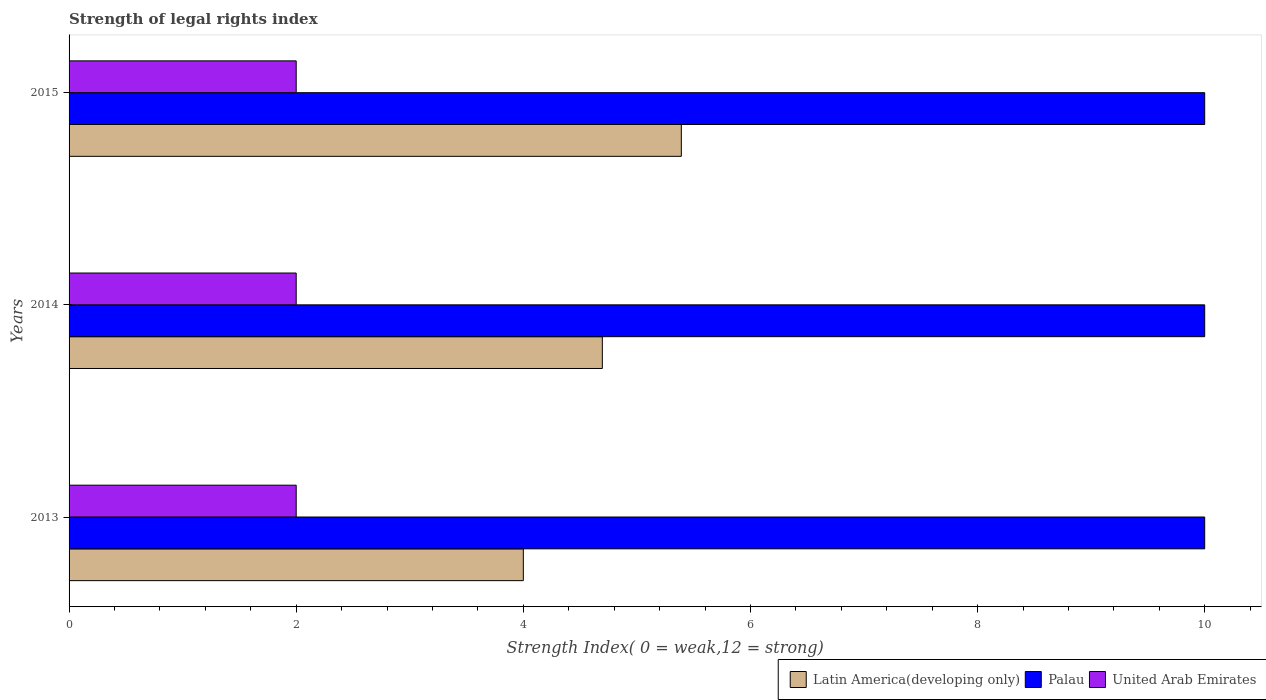How many bars are there on the 1st tick from the top?
Keep it short and to the point. 3. In how many cases, is the number of bars for a given year not equal to the number of legend labels?
Your response must be concise. 0. What is the strength index in Latin America(developing only) in 2015?
Your response must be concise. 5.39. Across all years, what is the maximum strength index in Palau?
Your response must be concise. 10. Across all years, what is the minimum strength index in Latin America(developing only)?
Make the answer very short. 4. In which year was the strength index in United Arab Emirates minimum?
Ensure brevity in your answer.  2013. What is the total strength index in Latin America(developing only) in the graph?
Make the answer very short. 14.09. What is the difference between the strength index in Latin America(developing only) in 2013 and that in 2014?
Provide a succinct answer. -0.7. What is the difference between the strength index in Latin America(developing only) in 2014 and the strength index in United Arab Emirates in 2013?
Provide a short and direct response. 2.7. What is the average strength index in Latin America(developing only) per year?
Offer a terse response. 4.7. In the year 2014, what is the difference between the strength index in United Arab Emirates and strength index in Latin America(developing only)?
Offer a terse response. -2.7. Is the strength index in Palau in 2013 less than that in 2014?
Your response must be concise. No. What is the difference between the highest and the second highest strength index in Palau?
Make the answer very short. 0. What is the difference between the highest and the lowest strength index in Latin America(developing only)?
Your answer should be compact. 1.39. In how many years, is the strength index in United Arab Emirates greater than the average strength index in United Arab Emirates taken over all years?
Ensure brevity in your answer.  0. Is the sum of the strength index in United Arab Emirates in 2013 and 2015 greater than the maximum strength index in Latin America(developing only) across all years?
Give a very brief answer. No. What does the 2nd bar from the top in 2014 represents?
Your answer should be very brief. Palau. What does the 3rd bar from the bottom in 2015 represents?
Provide a short and direct response. United Arab Emirates. Is it the case that in every year, the sum of the strength index in Palau and strength index in Latin America(developing only) is greater than the strength index in United Arab Emirates?
Your response must be concise. Yes. How many bars are there?
Ensure brevity in your answer.  9. What is the difference between two consecutive major ticks on the X-axis?
Keep it short and to the point. 2. Does the graph contain any zero values?
Give a very brief answer. No. Does the graph contain grids?
Ensure brevity in your answer.  No. Where does the legend appear in the graph?
Provide a short and direct response. Bottom right. How many legend labels are there?
Make the answer very short. 3. How are the legend labels stacked?
Your answer should be compact. Horizontal. What is the title of the graph?
Provide a short and direct response. Strength of legal rights index. Does "Heavily indebted poor countries" appear as one of the legend labels in the graph?
Offer a terse response. No. What is the label or title of the X-axis?
Give a very brief answer. Strength Index( 0 = weak,12 = strong). What is the Strength Index( 0 = weak,12 = strong) of Latin America(developing only) in 2013?
Offer a very short reply. 4. What is the Strength Index( 0 = weak,12 = strong) of Palau in 2013?
Your answer should be very brief. 10. What is the Strength Index( 0 = weak,12 = strong) of United Arab Emirates in 2013?
Your answer should be compact. 2. What is the Strength Index( 0 = weak,12 = strong) in Latin America(developing only) in 2014?
Provide a succinct answer. 4.7. What is the Strength Index( 0 = weak,12 = strong) in Latin America(developing only) in 2015?
Provide a short and direct response. 5.39. What is the Strength Index( 0 = weak,12 = strong) in United Arab Emirates in 2015?
Offer a terse response. 2. Across all years, what is the maximum Strength Index( 0 = weak,12 = strong) in Latin America(developing only)?
Your response must be concise. 5.39. Across all years, what is the maximum Strength Index( 0 = weak,12 = strong) in United Arab Emirates?
Ensure brevity in your answer.  2. Across all years, what is the minimum Strength Index( 0 = weak,12 = strong) in United Arab Emirates?
Give a very brief answer. 2. What is the total Strength Index( 0 = weak,12 = strong) of Latin America(developing only) in the graph?
Your answer should be compact. 14.09. What is the total Strength Index( 0 = weak,12 = strong) in Palau in the graph?
Make the answer very short. 30. What is the total Strength Index( 0 = weak,12 = strong) of United Arab Emirates in the graph?
Provide a succinct answer. 6. What is the difference between the Strength Index( 0 = weak,12 = strong) in Latin America(developing only) in 2013 and that in 2014?
Your response must be concise. -0.7. What is the difference between the Strength Index( 0 = weak,12 = strong) of Palau in 2013 and that in 2014?
Your answer should be compact. 0. What is the difference between the Strength Index( 0 = weak,12 = strong) of Latin America(developing only) in 2013 and that in 2015?
Offer a terse response. -1.39. What is the difference between the Strength Index( 0 = weak,12 = strong) of Latin America(developing only) in 2014 and that in 2015?
Provide a succinct answer. -0.7. What is the difference between the Strength Index( 0 = weak,12 = strong) in United Arab Emirates in 2014 and that in 2015?
Give a very brief answer. 0. What is the difference between the Strength Index( 0 = weak,12 = strong) of Latin America(developing only) in 2013 and the Strength Index( 0 = weak,12 = strong) of United Arab Emirates in 2014?
Your answer should be compact. 2. What is the difference between the Strength Index( 0 = weak,12 = strong) in Latin America(developing only) in 2013 and the Strength Index( 0 = weak,12 = strong) in Palau in 2015?
Provide a succinct answer. -6. What is the difference between the Strength Index( 0 = weak,12 = strong) of Latin America(developing only) in 2013 and the Strength Index( 0 = weak,12 = strong) of United Arab Emirates in 2015?
Offer a very short reply. 2. What is the difference between the Strength Index( 0 = weak,12 = strong) in Palau in 2013 and the Strength Index( 0 = weak,12 = strong) in United Arab Emirates in 2015?
Your answer should be very brief. 8. What is the difference between the Strength Index( 0 = weak,12 = strong) of Latin America(developing only) in 2014 and the Strength Index( 0 = weak,12 = strong) of Palau in 2015?
Provide a short and direct response. -5.3. What is the difference between the Strength Index( 0 = weak,12 = strong) of Latin America(developing only) in 2014 and the Strength Index( 0 = weak,12 = strong) of United Arab Emirates in 2015?
Offer a very short reply. 2.7. What is the difference between the Strength Index( 0 = weak,12 = strong) in Palau in 2014 and the Strength Index( 0 = weak,12 = strong) in United Arab Emirates in 2015?
Make the answer very short. 8. What is the average Strength Index( 0 = weak,12 = strong) of Latin America(developing only) per year?
Your answer should be compact. 4.7. In the year 2013, what is the difference between the Strength Index( 0 = weak,12 = strong) of Latin America(developing only) and Strength Index( 0 = weak,12 = strong) of Palau?
Keep it short and to the point. -6. In the year 2013, what is the difference between the Strength Index( 0 = weak,12 = strong) in Palau and Strength Index( 0 = weak,12 = strong) in United Arab Emirates?
Your answer should be very brief. 8. In the year 2014, what is the difference between the Strength Index( 0 = weak,12 = strong) of Latin America(developing only) and Strength Index( 0 = weak,12 = strong) of Palau?
Keep it short and to the point. -5.3. In the year 2014, what is the difference between the Strength Index( 0 = weak,12 = strong) in Latin America(developing only) and Strength Index( 0 = weak,12 = strong) in United Arab Emirates?
Keep it short and to the point. 2.7. In the year 2015, what is the difference between the Strength Index( 0 = weak,12 = strong) in Latin America(developing only) and Strength Index( 0 = weak,12 = strong) in Palau?
Give a very brief answer. -4.61. In the year 2015, what is the difference between the Strength Index( 0 = weak,12 = strong) of Latin America(developing only) and Strength Index( 0 = weak,12 = strong) of United Arab Emirates?
Offer a terse response. 3.39. In the year 2015, what is the difference between the Strength Index( 0 = weak,12 = strong) in Palau and Strength Index( 0 = weak,12 = strong) in United Arab Emirates?
Give a very brief answer. 8. What is the ratio of the Strength Index( 0 = weak,12 = strong) in Latin America(developing only) in 2013 to that in 2014?
Offer a terse response. 0.85. What is the ratio of the Strength Index( 0 = weak,12 = strong) in Latin America(developing only) in 2013 to that in 2015?
Offer a terse response. 0.74. What is the ratio of the Strength Index( 0 = weak,12 = strong) in Palau in 2013 to that in 2015?
Offer a terse response. 1. What is the ratio of the Strength Index( 0 = weak,12 = strong) in Latin America(developing only) in 2014 to that in 2015?
Your answer should be compact. 0.87. What is the ratio of the Strength Index( 0 = weak,12 = strong) of United Arab Emirates in 2014 to that in 2015?
Offer a very short reply. 1. What is the difference between the highest and the second highest Strength Index( 0 = weak,12 = strong) in Latin America(developing only)?
Ensure brevity in your answer.  0.7. What is the difference between the highest and the lowest Strength Index( 0 = weak,12 = strong) of Latin America(developing only)?
Your answer should be compact. 1.39. 